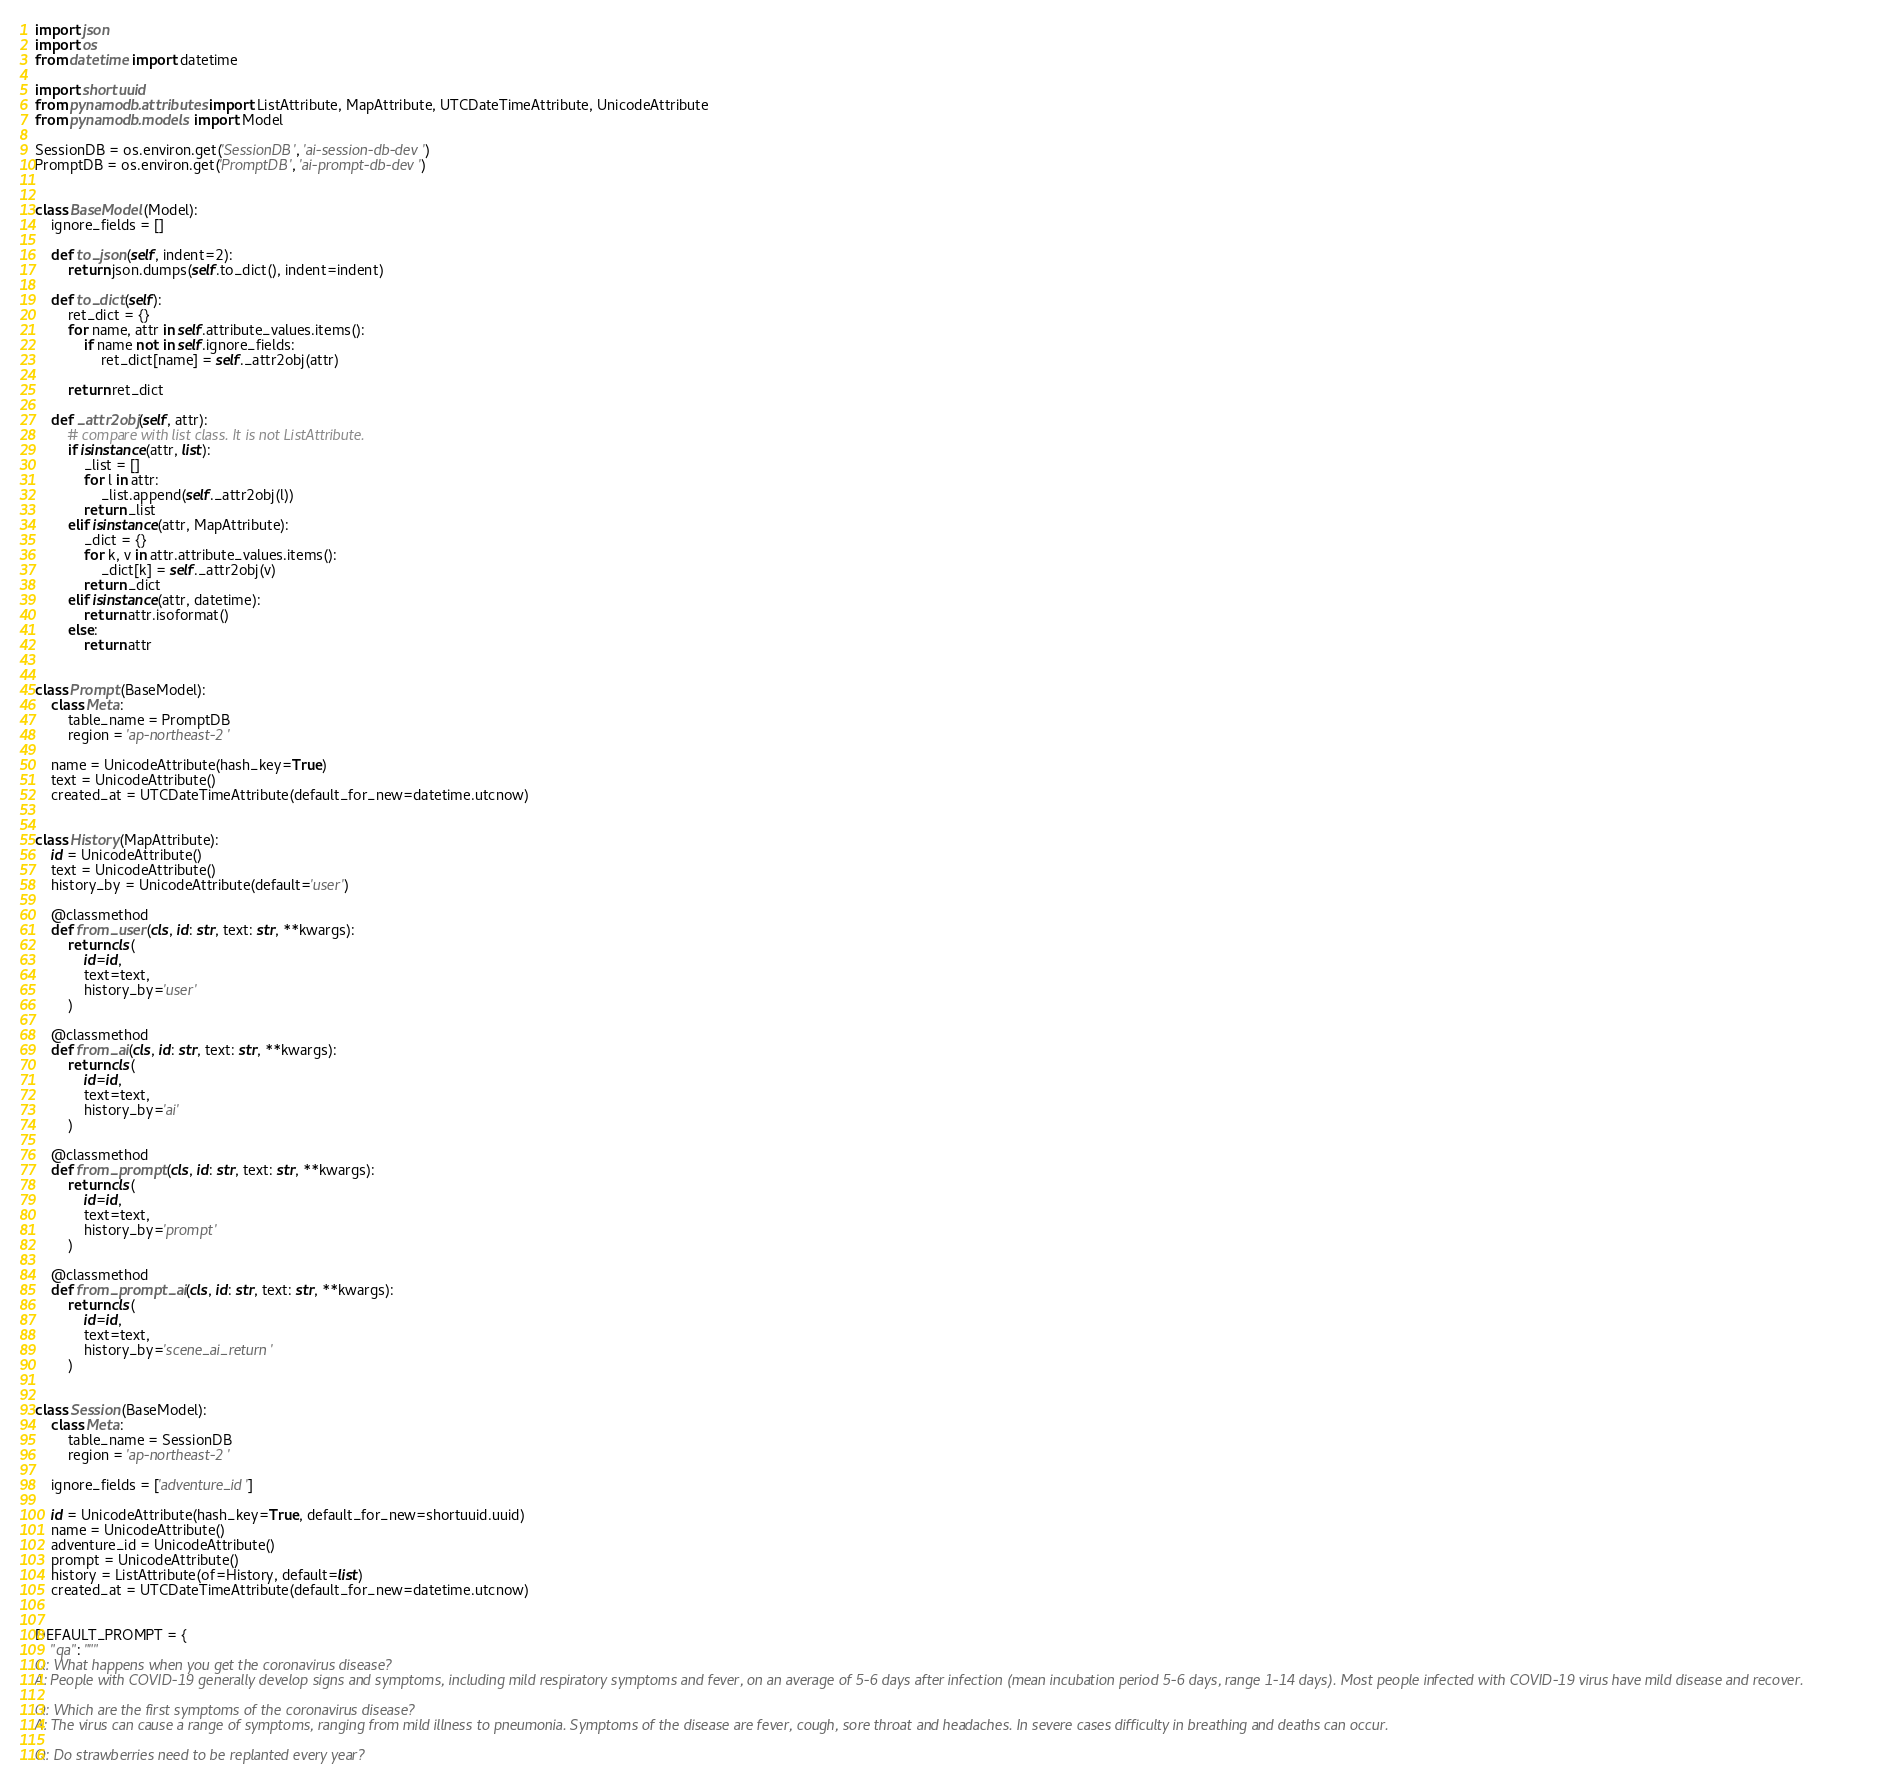Convert code to text. <code><loc_0><loc_0><loc_500><loc_500><_Python_>import json
import os
from datetime import datetime

import shortuuid
from pynamodb.attributes import ListAttribute, MapAttribute, UTCDateTimeAttribute, UnicodeAttribute
from pynamodb.models import Model

SessionDB = os.environ.get('SessionDB', 'ai-session-db-dev')
PromptDB = os.environ.get('PromptDB', 'ai-prompt-db-dev')


class BaseModel(Model):
    ignore_fields = []

    def to_json(self, indent=2):
        return json.dumps(self.to_dict(), indent=indent)

    def to_dict(self):
        ret_dict = {}
        for name, attr in self.attribute_values.items():
            if name not in self.ignore_fields:
                ret_dict[name] = self._attr2obj(attr)

        return ret_dict

    def _attr2obj(self, attr):
        # compare with list class. It is not ListAttribute.
        if isinstance(attr, list):
            _list = []
            for l in attr:
                _list.append(self._attr2obj(l))
            return _list
        elif isinstance(attr, MapAttribute):
            _dict = {}
            for k, v in attr.attribute_values.items():
                _dict[k] = self._attr2obj(v)
            return _dict
        elif isinstance(attr, datetime):
            return attr.isoformat()
        else:
            return attr


class Prompt(BaseModel):
    class Meta:
        table_name = PromptDB
        region = 'ap-northeast-2'

    name = UnicodeAttribute(hash_key=True)
    text = UnicodeAttribute()
    created_at = UTCDateTimeAttribute(default_for_new=datetime.utcnow)


class History(MapAttribute):
    id = UnicodeAttribute()
    text = UnicodeAttribute()
    history_by = UnicodeAttribute(default='user')

    @classmethod
    def from_user(cls, id: str, text: str, **kwargs):
        return cls(
            id=id,
            text=text,
            history_by='user'
        )

    @classmethod
    def from_ai(cls, id: str, text: str, **kwargs):
        return cls(
            id=id,
            text=text,
            history_by='ai'
        )

    @classmethod
    def from_prompt(cls, id: str, text: str, **kwargs):
        return cls(
            id=id,
            text=text,
            history_by='prompt'
        )

    @classmethod
    def from_prompt_ai(cls, id: str, text: str, **kwargs):
        return cls(
            id=id,
            text=text,
            history_by='scene_ai_return'
        )


class Session(BaseModel):
    class Meta:
        table_name = SessionDB
        region = 'ap-northeast-2'

    ignore_fields = ['adventure_id']

    id = UnicodeAttribute(hash_key=True, default_for_new=shortuuid.uuid)
    name = UnicodeAttribute()
    adventure_id = UnicodeAttribute()
    prompt = UnicodeAttribute()
    history = ListAttribute(of=History, default=list)
    created_at = UTCDateTimeAttribute(default_for_new=datetime.utcnow)


DEFAULT_PROMPT = {
    "qa": """
Q: What happens when you get the coronavirus disease?
A: People with COVID-19 generally develop signs and symptoms, including mild respiratory symptoms and fever, on an average of 5-6 days after infection (mean incubation period 5-6 days, range 1-14 days). Most people infected with COVID-19 virus have mild disease and recover.

Q: Which are the first symptoms of the coronavirus disease?
A: The virus can cause a range of symptoms, ranging from mild illness to pneumonia. Symptoms of the disease are fever, cough, sore throat and headaches. In severe cases difficulty in breathing and deaths can occur.

Q: Do strawberries need to be replanted every year?</code> 